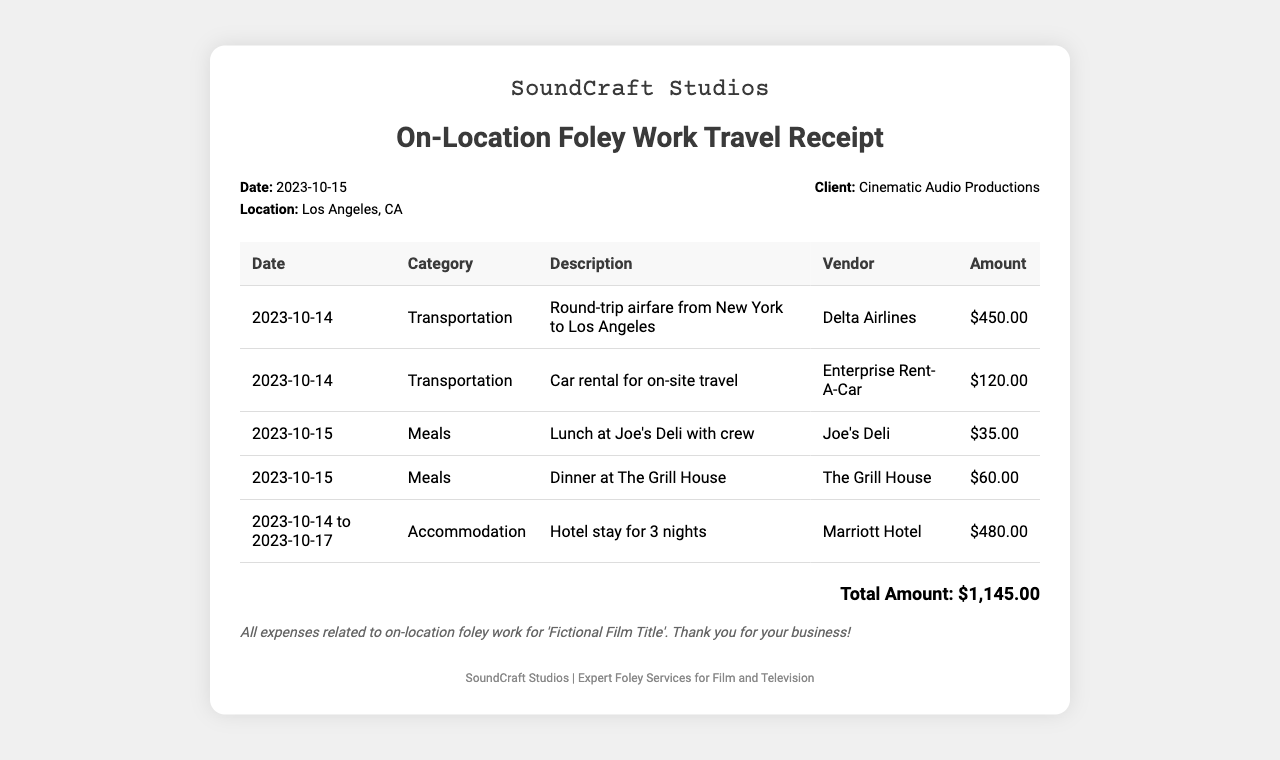What is the total amount? The total amount is calculated from the sum of all listed expenses in the document, which equals $450.00 + $120.00 + $35.00 + $60.00 + $480.00.
Answer: $1,145.00 What is the date of the receipt? The date of the receipt is clearly stated in the document under the date section.
Answer: 2023-10-15 What is the name of the hotel? The hotel name is mentioned in the accommodation expense description.
Answer: Marriott Hotel How many nights was the hotel stay? The document specifies a hotel stay for a range of dates that indicates the length.
Answer: 3 nights Which airline was used for transportation? The vendor for transportation expense is listed in the table under transportation.
Answer: Delta Airlines How much was spent on meals? The meals section includes two entries which can be added together to find the total meal cost.
Answer: $95.00 What was the purpose of the trip? The purpose of the trip is indicated in the notes section of the receipt.
Answer: On-location foley work How long was the total travel duration? The receipt specifies accommodation dates which can help determine the length of the travel.
Answer: 4 days Which client is mentioned in the document? The name of the client is clearly stated in the info section of the receipt.
Answer: Cinematic Audio Productions 